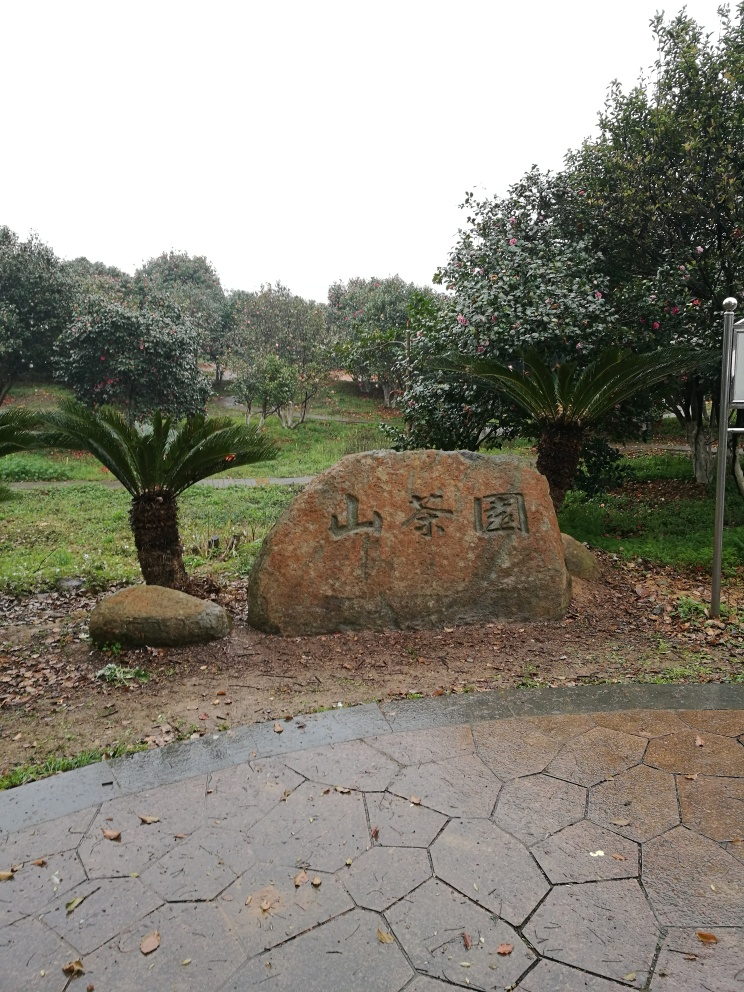What is written on the stone, and can you tell me about its significance? The characters on the stone appear to be in an East Asian script, likely Chinese, which may suggest a cultural or historical significance. However, without a clearer view or contextual knowledge, I'm unable to decipher them fully or speak to their specific meaning. 